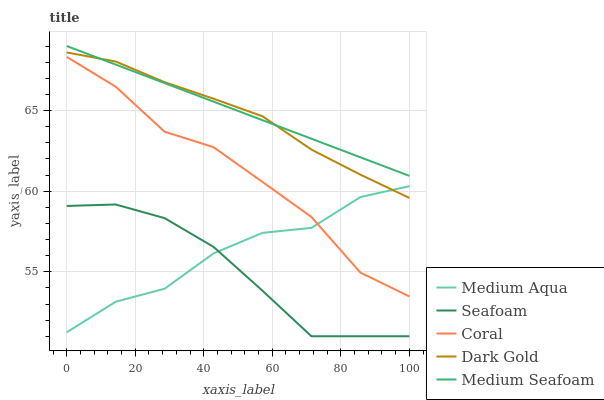Does Coral have the minimum area under the curve?
Answer yes or no. No. Does Coral have the maximum area under the curve?
Answer yes or no. No. Is Medium Aqua the smoothest?
Answer yes or no. No. Is Medium Aqua the roughest?
Answer yes or no. No. Does Coral have the lowest value?
Answer yes or no. No. Does Coral have the highest value?
Answer yes or no. No. Is Seafoam less than Dark Gold?
Answer yes or no. Yes. Is Coral greater than Seafoam?
Answer yes or no. Yes. Does Seafoam intersect Dark Gold?
Answer yes or no. No. 